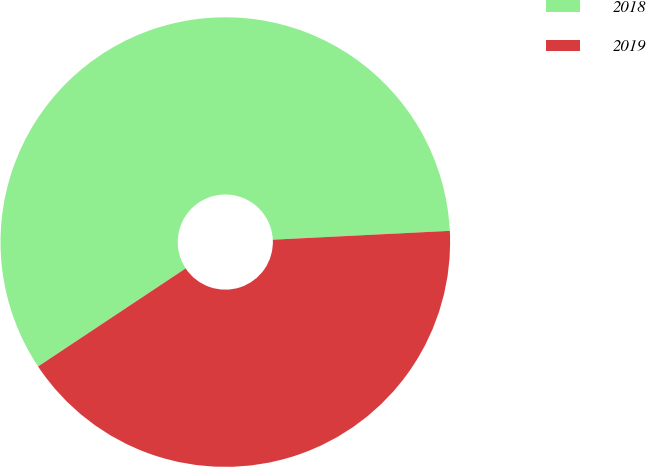Convert chart to OTSL. <chart><loc_0><loc_0><loc_500><loc_500><pie_chart><fcel>2018<fcel>2019<nl><fcel>58.54%<fcel>41.46%<nl></chart> 